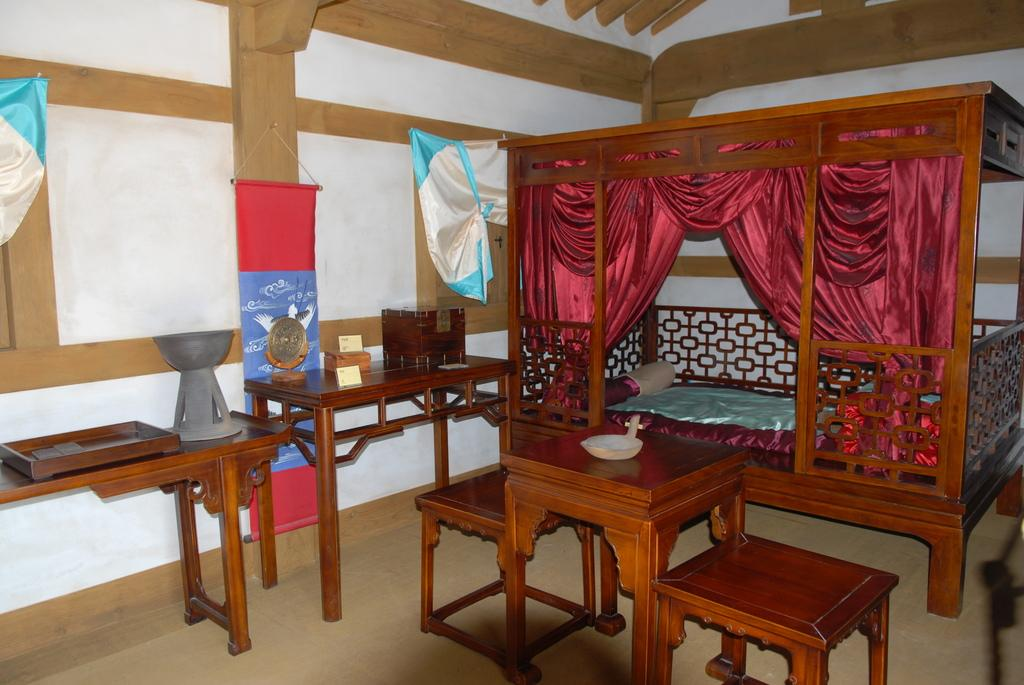What type of furniture is present in the image? There are tables and stools in the image. What type of bed is in the image? There is a cot with a bed in the image. What additional object can be seen in the image? There is a shield in the image. What is on the floor in the image? There are objects on the floor in the image. What can be seen in the background of the image? There is a wall, curtains, and a cupboard in the background of the image. Can you hear the bells ringing in the image? There are no bells present in the image, so it is not possible to hear them ringing. 